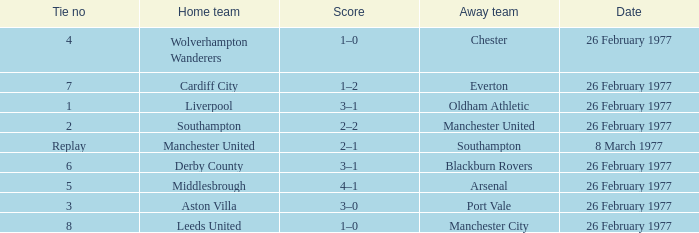What's the score when the tie number was replay? 2–1. 